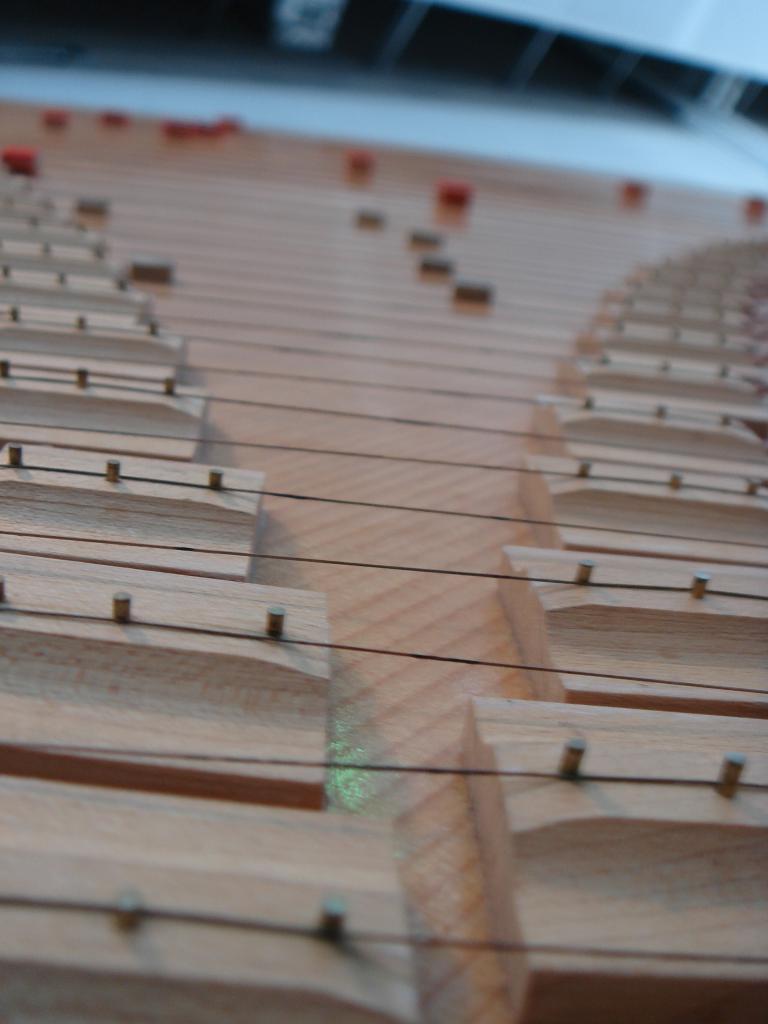Can you describe this image briefly? In this image I can see the wooden object which is cream in color and few strings to it. I can see the blurry background in which I can see few red and black colored objects. 